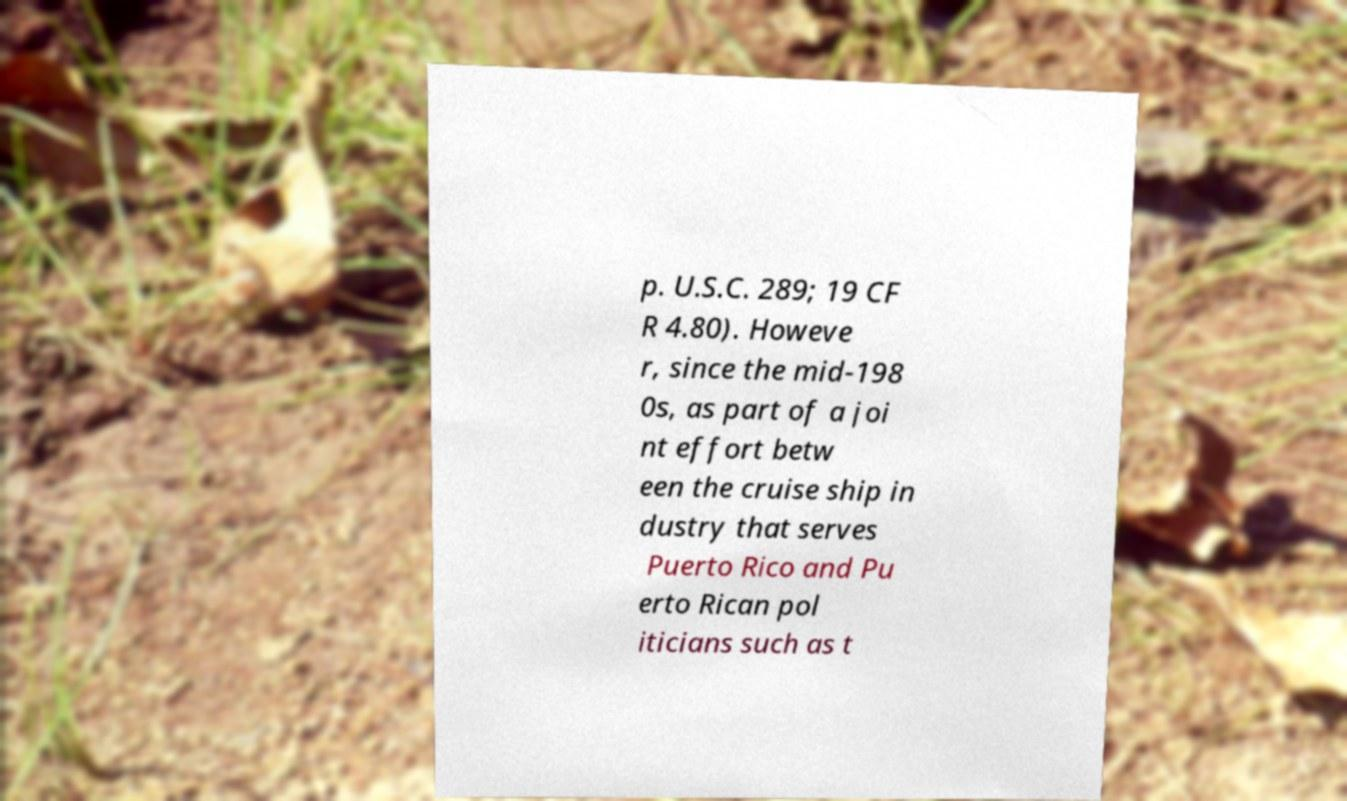Could you extract and type out the text from this image? p. U.S.C. 289; 19 CF R 4.80). Howeve r, since the mid-198 0s, as part of a joi nt effort betw een the cruise ship in dustry that serves Puerto Rico and Pu erto Rican pol iticians such as t 